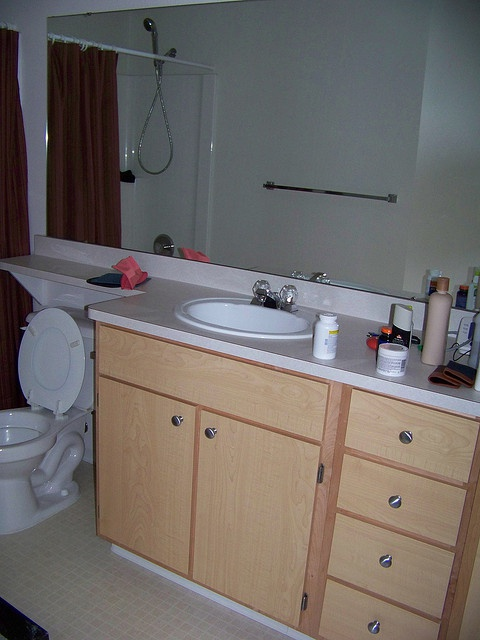Describe the objects in this image and their specific colors. I can see toilet in purple and gray tones, sink in purple, darkgray, and gray tones, bottle in purple, gray, and maroon tones, and bottle in black, lavender, and darkgray tones in this image. 